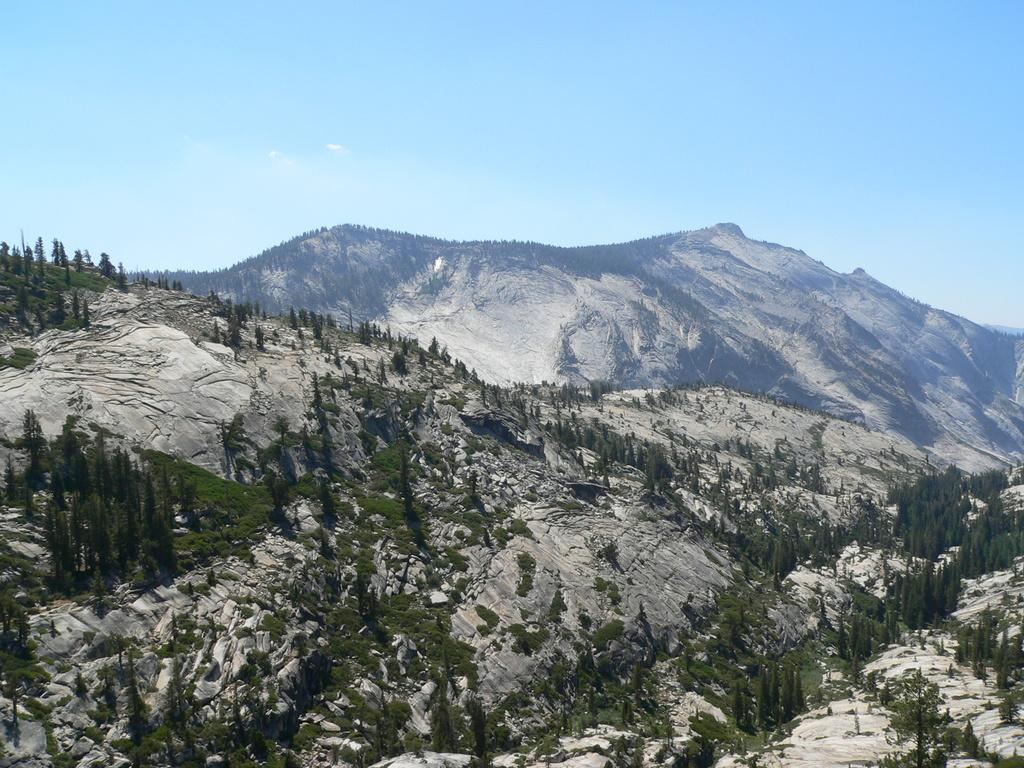What type of landscape feature is present at the bottom of the image? There are hills and trees at the bottom of the image. Can you describe the vegetation at the bottom of the image? There are trees at the bottom of the image. What can be seen in the background of the image? There are trees and hills in the background of the image. What is visible at the top of the image? The sky is visible at the top of the image. What type of plants are growing on the rail in the image? There is no rail present in the image, so no plants are growing on it. 